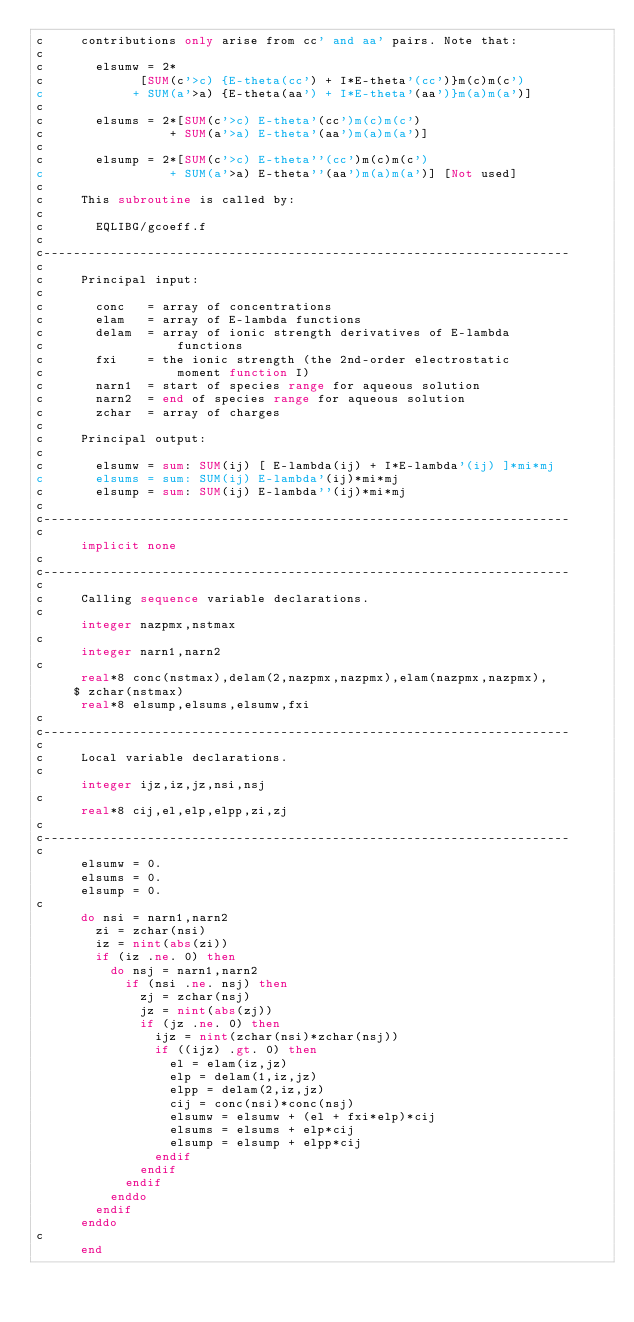<code> <loc_0><loc_0><loc_500><loc_500><_FORTRAN_>c     contributions only arise from cc' and aa' pairs. Note that:
c
c       elsumw = 2*
c             [SUM(c'>c) {E-theta(cc') + I*E-theta'(cc')}m(c)m(c')
c            + SUM(a'>a) {E-theta(aa') + I*E-theta'(aa')}m(a)m(a')]
c
c       elsums = 2*[SUM(c'>c) E-theta'(cc')m(c)m(c')
c                 + SUM(a'>a) E-theta'(aa')m(a)m(a')]
c
c       elsump = 2*[SUM(c'>c) E-theta''(cc')m(c)m(c')
c                 + SUM(a'>a) E-theta''(aa')m(a)m(a')] [Not used]
c
c     This subroutine is called by:
c
c       EQLIBG/gcoeff.f
c
c-----------------------------------------------------------------------
c
c     Principal input:
c
c       conc   = array of concentrations
c       elam   = array of E-lambda functions
c       delam  = array of ionic strength derivatives of E-lambda
c                  functions
c       fxi    = the ionic strength (the 2nd-order electrostatic
c                  moment function I)
c       narn1  = start of species range for aqueous solution
c       narn2  = end of species range for aqueous solution
c       zchar  = array of charges
c
c     Principal output:
c
c       elsumw = sum: SUM(ij) [ E-lambda(ij) + I*E-lambda'(ij) ]*mi*mj
c       elsums = sum: SUM(ij) E-lambda'(ij)*mi*mj
c       elsump = sum: SUM(ij) E-lambda''(ij)*mi*mj
c
c-----------------------------------------------------------------------
c
      implicit none
c
c-----------------------------------------------------------------------
c
c     Calling sequence variable declarations.
c
      integer nazpmx,nstmax
c
      integer narn1,narn2
c
      real*8 conc(nstmax),delam(2,nazpmx,nazpmx),elam(nazpmx,nazpmx),
     $ zchar(nstmax)
      real*8 elsump,elsums,elsumw,fxi
c
c-----------------------------------------------------------------------
c
c     Local variable declarations.
c
      integer ijz,iz,jz,nsi,nsj
c
      real*8 cij,el,elp,elpp,zi,zj
c
c-----------------------------------------------------------------------
c
      elsumw = 0.
      elsums = 0.
      elsump = 0.
c
      do nsi = narn1,narn2
        zi = zchar(nsi)
        iz = nint(abs(zi))
        if (iz .ne. 0) then
          do nsj = narn1,narn2
            if (nsi .ne. nsj) then
              zj = zchar(nsj)
              jz = nint(abs(zj))
              if (jz .ne. 0) then
                ijz = nint(zchar(nsi)*zchar(nsj))
                if ((ijz) .gt. 0) then
                  el = elam(iz,jz)
                  elp = delam(1,iz,jz)
                  elpp = delam(2,iz,jz)
                  cij = conc(nsi)*conc(nsj)
                  elsumw = elsumw + (el + fxi*elp)*cij
                  elsums = elsums + elp*cij
                  elsump = elsump + elpp*cij
                endif
              endif
            endif
          enddo
        endif
      enddo
c
      end
</code> 